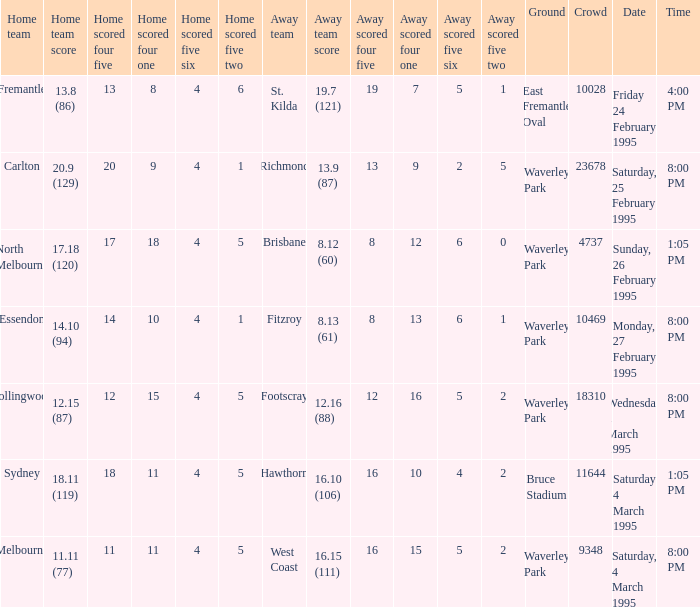Name the time for saturday 4 march 1995 1:05 PM. Write the full table. {'header': ['Home team', 'Home team score', 'Home scored four five', 'Home scored four one', 'Home scored five six', 'Home scored five two', 'Away team', 'Away team score', 'Away scored four five', 'Away scored four one', 'Away scored five six', 'Away scored five two', 'Ground', 'Crowd', 'Date', 'Time'], 'rows': [['Fremantle', '13.8 (86)', '13', '8', '4', '6', 'St. Kilda', '19.7 (121)', '19', '7', '5', '1', 'East Fremantle Oval', '10028', 'Friday 24 February 1995', '4:00 PM'], ['Carlton', '20.9 (129)', '20', '9', '4', '1', 'Richmond', '13.9 (87)', '13', '9', '2', '5', 'Waverley Park', '23678', 'Saturday, 25 February 1995', '8:00 PM'], ['North Melbourne', '17.18 (120)', '17', '18', '4', '5', 'Brisbane', '8.12 (60)', '8', '12', '6', '0', 'Waverley Park', '4737', 'Sunday, 26 February 1995', '1:05 PM'], ['Essendon', '14.10 (94)', '14', '10', '4', '1', 'Fitzroy', '8.13 (61)', '8', '13', '6', '1', 'Waverley Park', '10469', 'Monday, 27 February 1995', '8:00 PM'], ['Collingwood', '12.15 (87)', '12', '15', '4', '5', 'Footscray', '12.16 (88)', '12', '16', '5', '2', 'Waverley Park', '18310', 'Wednesday 1 March 1995', '8:00 PM'], ['Sydney', '18.11 (119)', '18', '11', '4', '5', 'Hawthorn', '16.10 (106)', '16', '10', '4', '2', 'Bruce Stadium', '11644', 'Saturday 4 March 1995', '1:05 PM'], ['Melbourne', '11.11 (77)', '11', '11', '4', '5', 'West Coast', '16.15 (111)', '16', '15', '5', '2', 'Waverley Park', '9348', 'Saturday, 4 March 1995', '8:00 PM']]} 